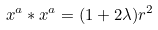<formula> <loc_0><loc_0><loc_500><loc_500>x ^ { a } \ast x ^ { a } = ( 1 + 2 \lambda ) r ^ { 2 }</formula> 